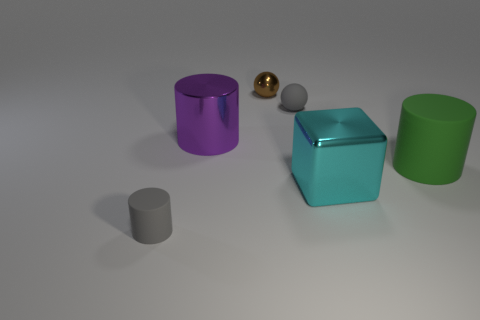Subtract all large cylinders. How many cylinders are left? 1 Subtract all purple cylinders. How many cylinders are left? 2 Subtract all balls. How many objects are left? 4 Add 2 small metal cylinders. How many small metal cylinders exist? 2 Add 3 big blue rubber cylinders. How many objects exist? 9 Subtract 0 green blocks. How many objects are left? 6 Subtract 1 cubes. How many cubes are left? 0 Subtract all green cylinders. Subtract all yellow blocks. How many cylinders are left? 2 Subtract all cyan cylinders. How many gray balls are left? 1 Subtract all cyan matte blocks. Subtract all cyan shiny blocks. How many objects are left? 5 